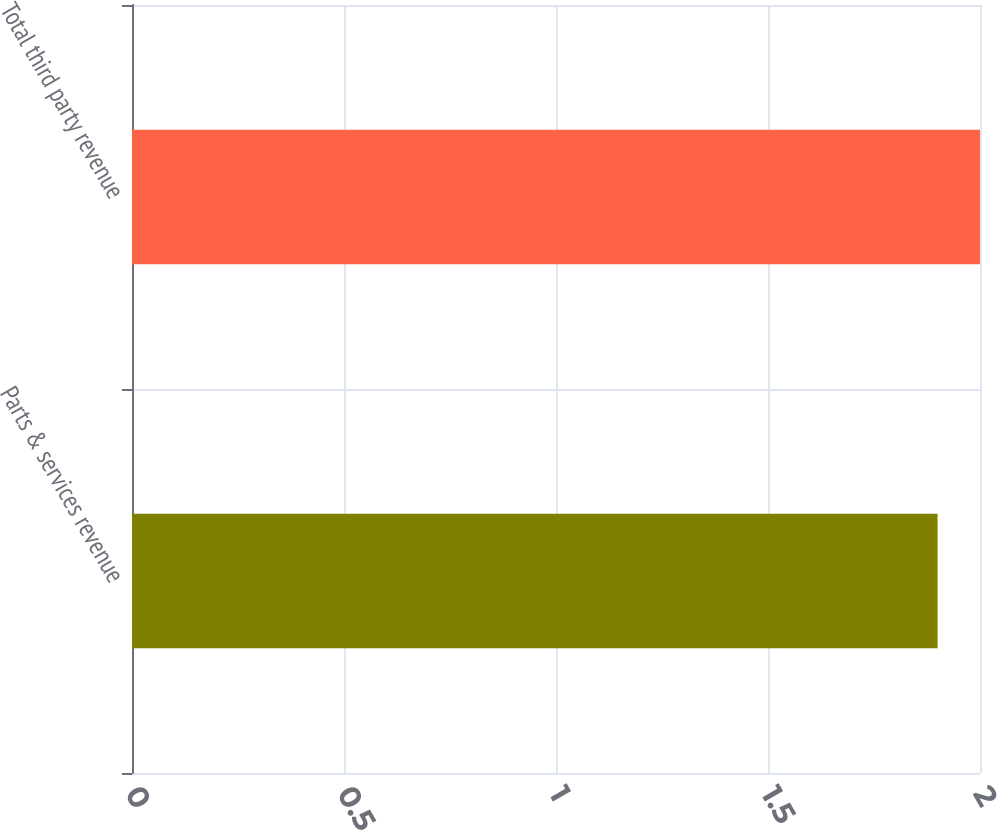Convert chart. <chart><loc_0><loc_0><loc_500><loc_500><bar_chart><fcel>Parts & services revenue<fcel>Total third party revenue<nl><fcel>1.9<fcel>2<nl></chart> 